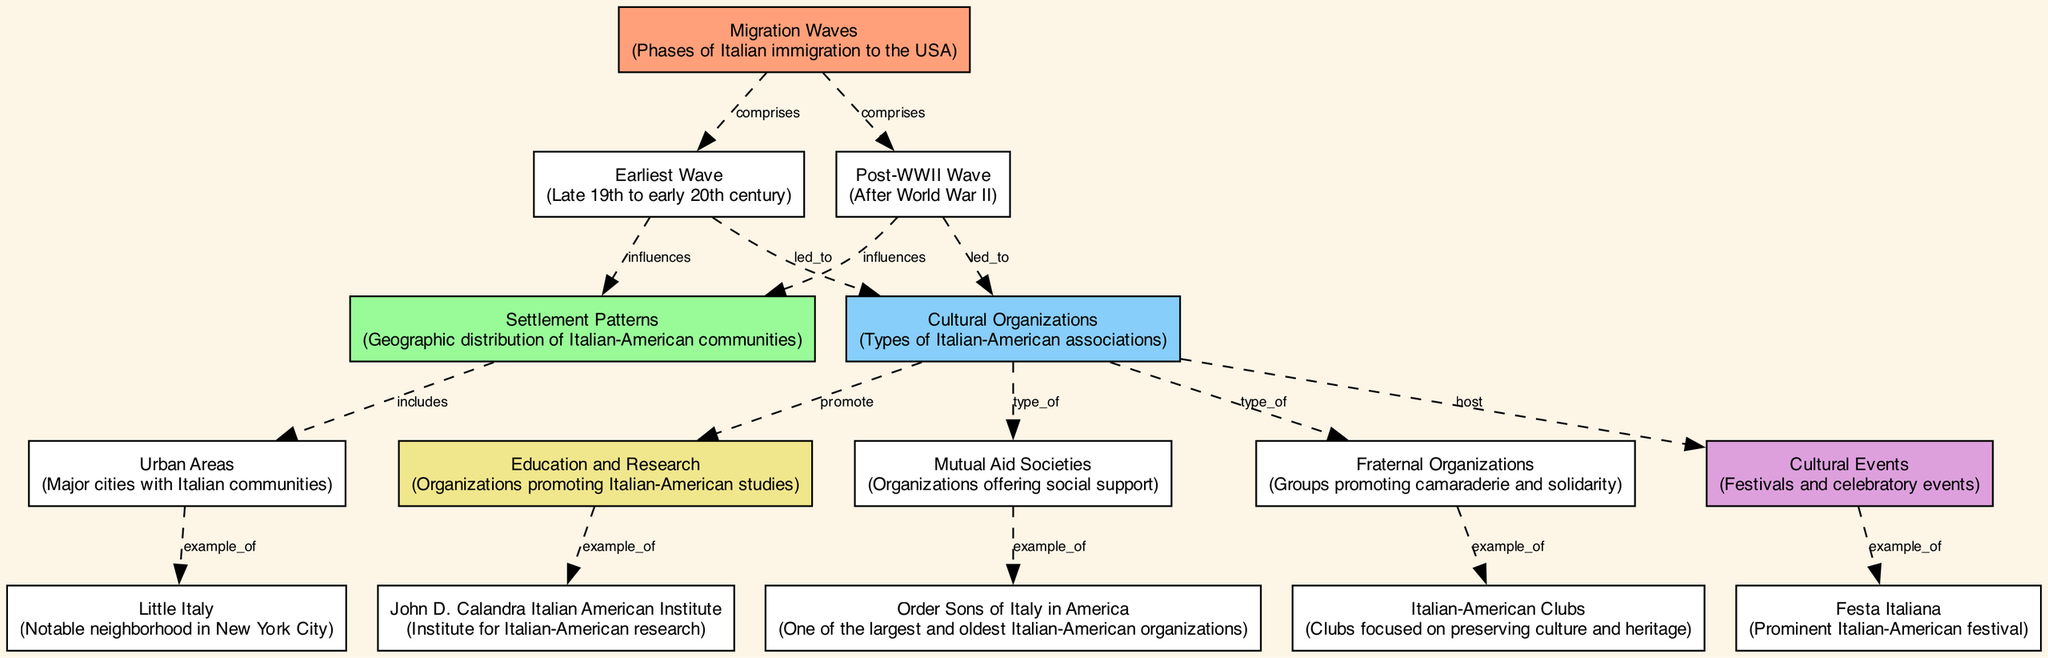What phases of immigration are represented in the diagram? The diagram has nodes for the earliest wave and post-WWII wave, which encompass the major migration waves of Italian immigrants to the USA. This structure indicates the two primary periods that characterize the immigration experience.
Answer: earliest wave, post-WWII wave How does the earliest wave influence settlement patterns? The diagram indicates a directed edge marked "influences" from the earliest wave node to the settlement patterns node. This suggests that the characteristics of the earliest group of Italian immigrants shaped the ways in which they settled in America.
Answer: influences What type of organization is the Order Sons of Italy in America? The diagram shows an edge labeled "example of" connecting the mutual aid societies node to the Order Sons of Italy in America. This indicates that the Order Sons of Italy is a specific instance of a mutual aid society, which serves as social support for Italian-Americans.
Answer: example of Which cultural organization hosts cultural events? According to the diagram, there is an edge from the cultural organizations node to the cultural events node labeled "host." This indicates that the broader category of cultural organizations is responsible for organizing various cultural events, such as festivals.
Answer: cultural organizations What is a specific example of a cultural event mentioned? The diagram contains a connection from the cultural events node to the festa italiana node labeled "example of." This indicates that festa italiana is a notable festival that is specifically categorized under cultural events.
Answer: festa italiana How do settlement patterns relate to urban areas? The diagram shows a directed edge labeled "includes" going from settlement patterns to urban areas. This means that urban areas are a subset of the broader concept of settlement patterns, which encompasses where Italian-American communities are established.
Answer: includes What is a key organization promoting education and research in Italian-American studies? The diagram connects the education and research node to the John D. Calandra Italian American Institute, showing a relationship marked "example of." This illustrates that the Calandra Institute is a primary organization in the realm of education and research pertaining to Italian-American studies.
Answer: John D. Calandra Italian American Institute What types of cultural organizations are listed in the diagram? The cultural organizations node is connected to three specific types: mutual aid societies, fraternal organizations, and Italian-American clubs, illustrating the various forms of Italian-American associations involved in cultural preservation and support.
Answer: mutual aid societies, fraternal organizations, Italian-American clubs What influences does the post-WWII wave have on cultural organizations? Similar to the earliest wave, there is a directed edge labeled "led to" from the post-WWII wave to the cultural organizations node in the diagram. This indicates that the post-WWII wave of immigration also significantly contributed to the development of cultural organizations within the Italian-American community.
Answer: led to 